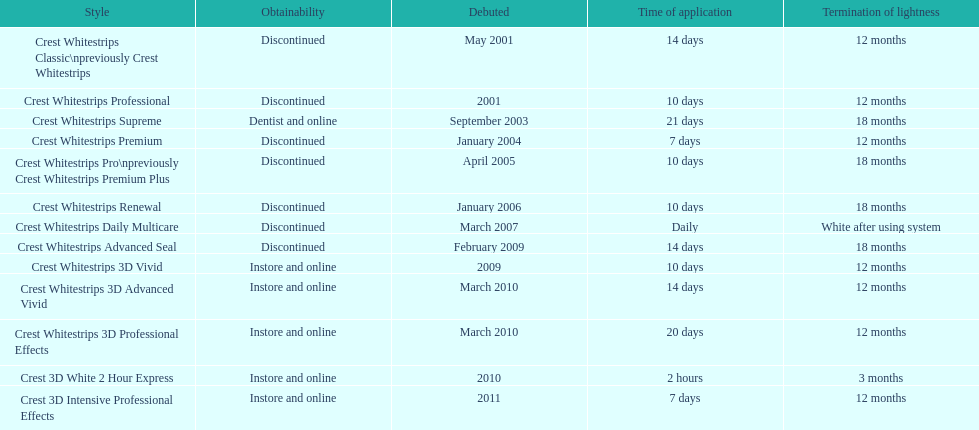Is each white strip discontinued? No. 